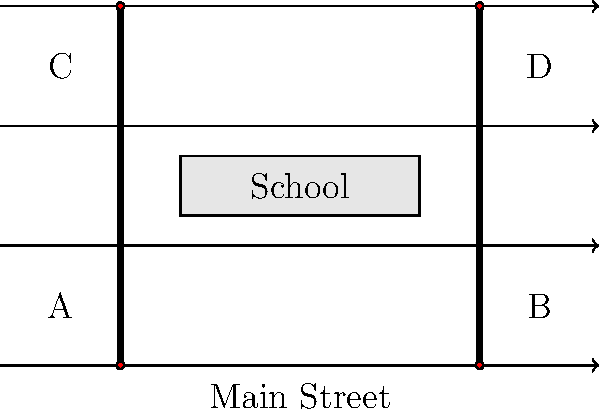Based on the street map of a school zone, which traffic flow pattern would best improve pedestrian safety while minimizing congestion during peak hours? Consider implementing a combination of strategies at points A, B, C, and D. To improve pedestrian safety and minimize congestion in this school zone, we need to consider several factors:

1. Crosswalk locations: There are two crosswalks, one at each end of the school building.

2. Traffic flow: Main Street has four lanes, two in each direction.

3. Peak hour congestion: This typically occurs during school drop-off and pick-up times.

4. Pedestrian safety: Students need to cross Main Street safely.

Step-by-step analysis:

1. At points A and C (left side of the map):
   - Implement a "No Right Turn on Red" policy during school hours to protect pedestrians in the crosswalks.
   - Install advanced warning signs for drivers approaching the school zone.

2. At points B and D (right side of the map):
   - Implement a "No Left Turn" policy during peak hours to reduce conflicts with pedestrians and improve traffic flow.
   - Install "School Zone" flashing lights to alert drivers.

3. For all intersections (A, B, C, and D):
   - Implement pedestrian countdown signals to help students cross safely.
   - Use leading pedestrian intervals (LPI) to give pedestrians a head start before vehicles get a green light.

4. On Main Street:
   - Reduce speed limits during school hours and enforce them strictly.
   - Install speed bumps or raised crosswalks to slow down traffic near the crosswalks.

5. Consider implementing a one-way traffic flow system on the streets parallel to Main Street (not shown in the map) to reduce congestion during peak hours.

6. Encourage the use of "Walking School Buses" or "Bike Trains" to reduce the number of vehicles in the school zone.

7. Designate specific drop-off and pick-up zones away from main pedestrian crossings to separate vehicle and pedestrian traffic.

By implementing these strategies, we can create a safer environment for pedestrians while also managing traffic flow efficiently during peak hours.
Answer: Implement "No Right Turn on Red" at A/C, "No Left Turn" at B/D during peak hours, pedestrian countdown signals and LPI at all intersections, reduced speed limits, and designated drop-off/pick-up zones. 